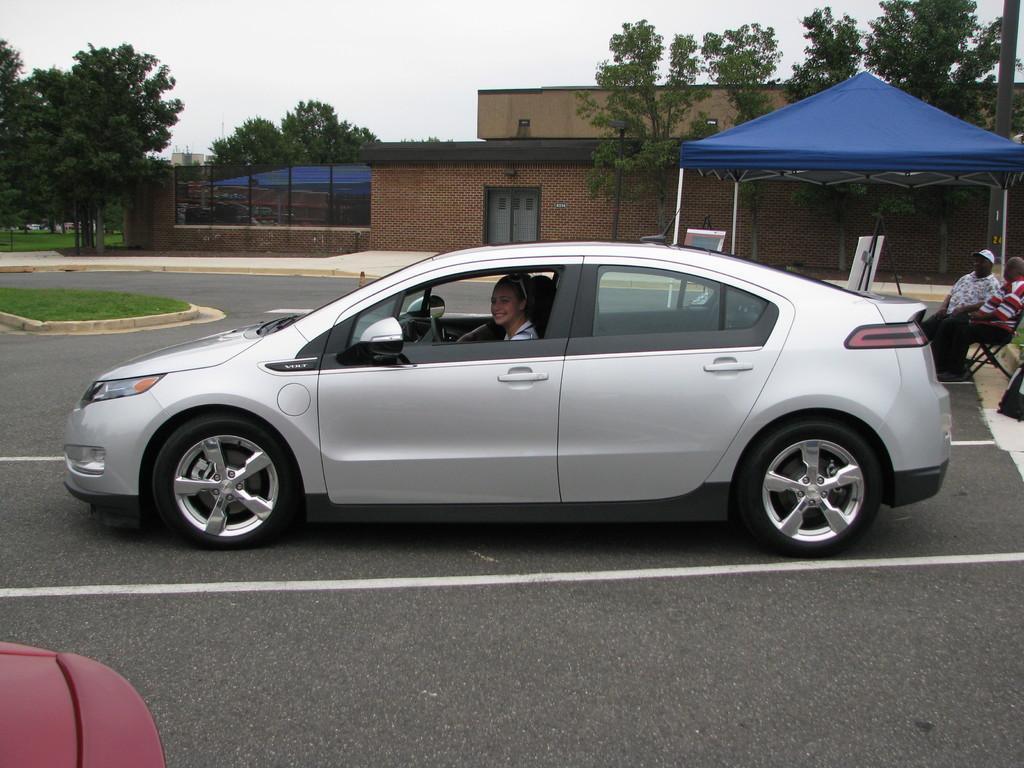In one or two sentences, can you explain what this image depicts? In this picture I can see couple of them sitting in the chairs and I can see a tent and couple of cars and I can see a woman sitting in the car and I can see a buildings and few trees and I can see cloudy sky and I can see couple of boards. 